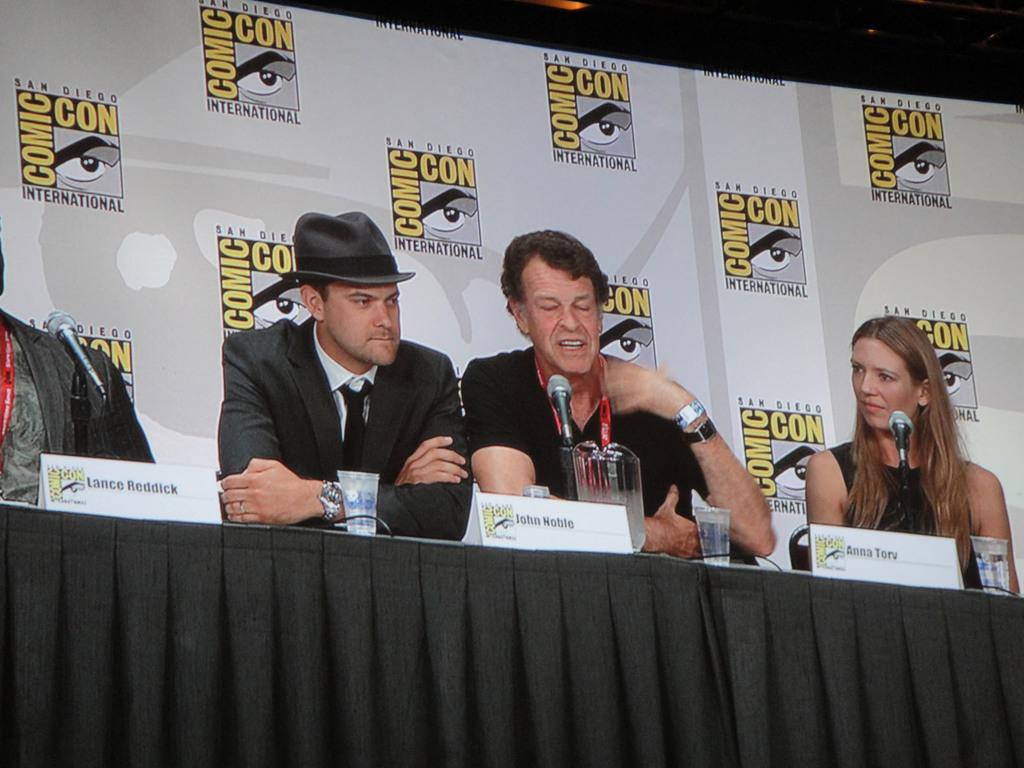What are the people in the image doing? The people in the image are sitting. What is on the table in the image? There is a table in the image with glasses, bottles, and a microphone (mike) on it. What can be seen hanging or displayed in the image? There is a banner visible in the image. What type of tramp can be seen jumping in the image? There is no tramp present in the image; it features people sitting at a table with various items. How many hooks are visible on the banner in the image? There are no hooks visible on the banner in the image; it is a single, unadorned banner. 